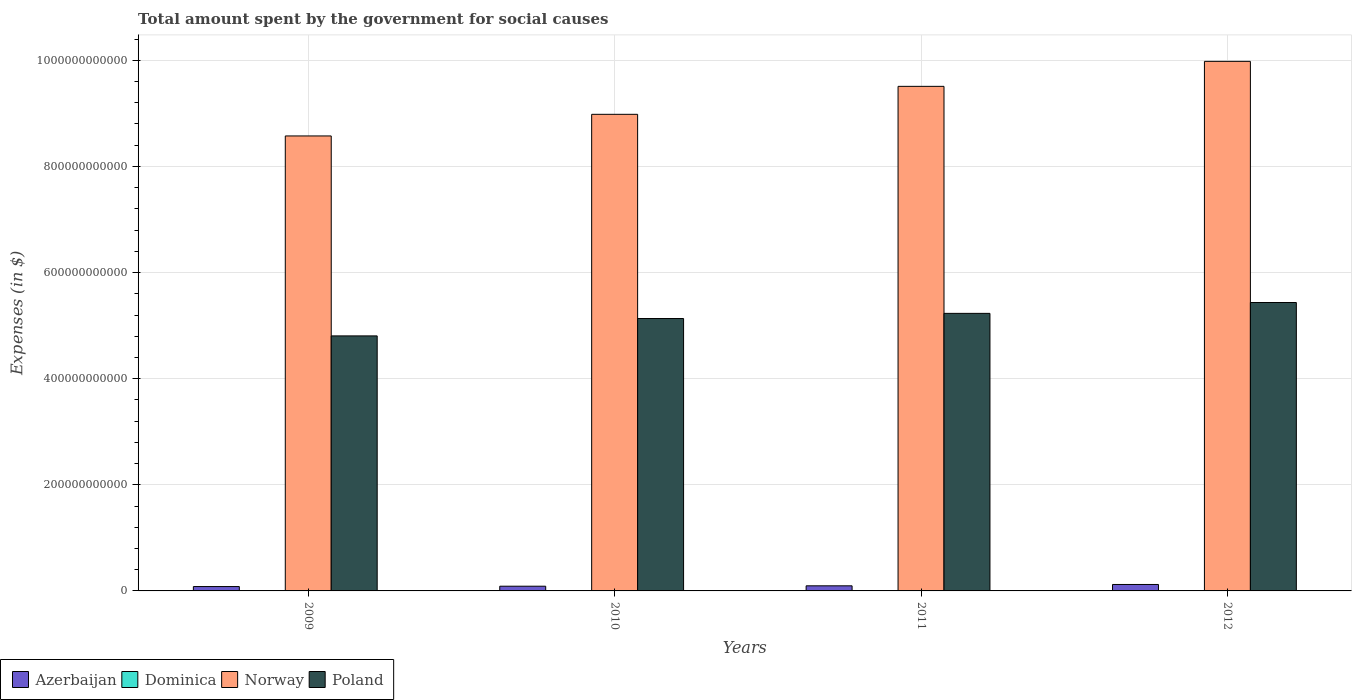Are the number of bars per tick equal to the number of legend labels?
Make the answer very short. Yes. Are the number of bars on each tick of the X-axis equal?
Keep it short and to the point. Yes. How many bars are there on the 2nd tick from the left?
Offer a very short reply. 4. In how many cases, is the number of bars for a given year not equal to the number of legend labels?
Provide a succinct answer. 0. What is the amount spent for social causes by the government in Dominica in 2012?
Offer a very short reply. 3.38e+08. Across all years, what is the maximum amount spent for social causes by the government in Azerbaijan?
Keep it short and to the point. 1.21e+1. Across all years, what is the minimum amount spent for social causes by the government in Norway?
Your answer should be very brief. 8.57e+11. In which year was the amount spent for social causes by the government in Poland maximum?
Provide a succinct answer. 2012. In which year was the amount spent for social causes by the government in Poland minimum?
Your answer should be compact. 2009. What is the total amount spent for social causes by the government in Poland in the graph?
Offer a terse response. 2.06e+12. What is the difference between the amount spent for social causes by the government in Dominica in 2010 and that in 2011?
Ensure brevity in your answer.  -1.13e+07. What is the difference between the amount spent for social causes by the government in Dominica in 2009 and the amount spent for social causes by the government in Poland in 2012?
Provide a succinct answer. -5.43e+11. What is the average amount spent for social causes by the government in Dominica per year?
Keep it short and to the point. 3.18e+08. In the year 2010, what is the difference between the amount spent for social causes by the government in Norway and amount spent for social causes by the government in Dominica?
Give a very brief answer. 8.98e+11. In how many years, is the amount spent for social causes by the government in Dominica greater than 1000000000000 $?
Offer a very short reply. 0. What is the ratio of the amount spent for social causes by the government in Azerbaijan in 2011 to that in 2012?
Give a very brief answer. 0.79. Is the amount spent for social causes by the government in Dominica in 2009 less than that in 2010?
Offer a terse response. Yes. Is the difference between the amount spent for social causes by the government in Norway in 2009 and 2011 greater than the difference between the amount spent for social causes by the government in Dominica in 2009 and 2011?
Give a very brief answer. No. What is the difference between the highest and the second highest amount spent for social causes by the government in Azerbaijan?
Your answer should be very brief. 2.52e+09. What is the difference between the highest and the lowest amount spent for social causes by the government in Norway?
Your answer should be very brief. 1.41e+11. In how many years, is the amount spent for social causes by the government in Azerbaijan greater than the average amount spent for social causes by the government in Azerbaijan taken over all years?
Offer a terse response. 1. Is the sum of the amount spent for social causes by the government in Norway in 2011 and 2012 greater than the maximum amount spent for social causes by the government in Poland across all years?
Provide a succinct answer. Yes. Is it the case that in every year, the sum of the amount spent for social causes by the government in Dominica and amount spent for social causes by the government in Azerbaijan is greater than the sum of amount spent for social causes by the government in Poland and amount spent for social causes by the government in Norway?
Your response must be concise. Yes. What does the 2nd bar from the right in 2012 represents?
Your answer should be compact. Norway. How many years are there in the graph?
Ensure brevity in your answer.  4. What is the difference between two consecutive major ticks on the Y-axis?
Provide a short and direct response. 2.00e+11. Does the graph contain any zero values?
Provide a short and direct response. No. How are the legend labels stacked?
Your answer should be very brief. Horizontal. What is the title of the graph?
Your answer should be compact. Total amount spent by the government for social causes. What is the label or title of the Y-axis?
Offer a very short reply. Expenses (in $). What is the Expenses (in $) in Azerbaijan in 2009?
Keep it short and to the point. 8.22e+09. What is the Expenses (in $) of Dominica in 2009?
Your answer should be very brief. 2.88e+08. What is the Expenses (in $) in Norway in 2009?
Give a very brief answer. 8.57e+11. What is the Expenses (in $) in Poland in 2009?
Your response must be concise. 4.81e+11. What is the Expenses (in $) of Azerbaijan in 2010?
Your response must be concise. 8.86e+09. What is the Expenses (in $) of Dominica in 2010?
Your response must be concise. 3.17e+08. What is the Expenses (in $) of Norway in 2010?
Give a very brief answer. 8.98e+11. What is the Expenses (in $) in Poland in 2010?
Provide a succinct answer. 5.13e+11. What is the Expenses (in $) in Azerbaijan in 2011?
Ensure brevity in your answer.  9.62e+09. What is the Expenses (in $) in Dominica in 2011?
Provide a short and direct response. 3.28e+08. What is the Expenses (in $) of Norway in 2011?
Offer a very short reply. 9.51e+11. What is the Expenses (in $) in Poland in 2011?
Offer a very short reply. 5.23e+11. What is the Expenses (in $) in Azerbaijan in 2012?
Make the answer very short. 1.21e+1. What is the Expenses (in $) of Dominica in 2012?
Keep it short and to the point. 3.38e+08. What is the Expenses (in $) of Norway in 2012?
Offer a very short reply. 9.98e+11. What is the Expenses (in $) in Poland in 2012?
Provide a short and direct response. 5.44e+11. Across all years, what is the maximum Expenses (in $) of Azerbaijan?
Provide a short and direct response. 1.21e+1. Across all years, what is the maximum Expenses (in $) of Dominica?
Provide a succinct answer. 3.38e+08. Across all years, what is the maximum Expenses (in $) of Norway?
Keep it short and to the point. 9.98e+11. Across all years, what is the maximum Expenses (in $) in Poland?
Give a very brief answer. 5.44e+11. Across all years, what is the minimum Expenses (in $) in Azerbaijan?
Ensure brevity in your answer.  8.22e+09. Across all years, what is the minimum Expenses (in $) in Dominica?
Keep it short and to the point. 2.88e+08. Across all years, what is the minimum Expenses (in $) in Norway?
Provide a succinct answer. 8.57e+11. Across all years, what is the minimum Expenses (in $) of Poland?
Make the answer very short. 4.81e+11. What is the total Expenses (in $) in Azerbaijan in the graph?
Offer a terse response. 3.88e+1. What is the total Expenses (in $) in Dominica in the graph?
Your response must be concise. 1.27e+09. What is the total Expenses (in $) of Norway in the graph?
Provide a succinct answer. 3.70e+12. What is the total Expenses (in $) in Poland in the graph?
Provide a succinct answer. 2.06e+12. What is the difference between the Expenses (in $) of Azerbaijan in 2009 and that in 2010?
Offer a very short reply. -6.47e+08. What is the difference between the Expenses (in $) in Dominica in 2009 and that in 2010?
Your response must be concise. -2.83e+07. What is the difference between the Expenses (in $) of Norway in 2009 and that in 2010?
Keep it short and to the point. -4.08e+1. What is the difference between the Expenses (in $) of Poland in 2009 and that in 2010?
Provide a short and direct response. -3.28e+1. What is the difference between the Expenses (in $) in Azerbaijan in 2009 and that in 2011?
Your answer should be compact. -1.41e+09. What is the difference between the Expenses (in $) of Dominica in 2009 and that in 2011?
Make the answer very short. -3.96e+07. What is the difference between the Expenses (in $) in Norway in 2009 and that in 2011?
Your answer should be compact. -9.35e+1. What is the difference between the Expenses (in $) in Poland in 2009 and that in 2011?
Give a very brief answer. -4.25e+1. What is the difference between the Expenses (in $) of Azerbaijan in 2009 and that in 2012?
Your response must be concise. -3.93e+09. What is the difference between the Expenses (in $) of Dominica in 2009 and that in 2012?
Your answer should be compact. -4.95e+07. What is the difference between the Expenses (in $) in Norway in 2009 and that in 2012?
Your answer should be very brief. -1.41e+11. What is the difference between the Expenses (in $) of Poland in 2009 and that in 2012?
Make the answer very short. -6.29e+1. What is the difference between the Expenses (in $) of Azerbaijan in 2010 and that in 2011?
Your response must be concise. -7.60e+08. What is the difference between the Expenses (in $) in Dominica in 2010 and that in 2011?
Your response must be concise. -1.13e+07. What is the difference between the Expenses (in $) in Norway in 2010 and that in 2011?
Provide a short and direct response. -5.27e+1. What is the difference between the Expenses (in $) in Poland in 2010 and that in 2011?
Make the answer very short. -9.70e+09. What is the difference between the Expenses (in $) of Azerbaijan in 2010 and that in 2012?
Your answer should be compact. -3.28e+09. What is the difference between the Expenses (in $) in Dominica in 2010 and that in 2012?
Your answer should be very brief. -2.12e+07. What is the difference between the Expenses (in $) of Norway in 2010 and that in 2012?
Offer a very short reply. -9.98e+1. What is the difference between the Expenses (in $) in Poland in 2010 and that in 2012?
Offer a very short reply. -3.02e+1. What is the difference between the Expenses (in $) in Azerbaijan in 2011 and that in 2012?
Ensure brevity in your answer.  -2.52e+09. What is the difference between the Expenses (in $) in Dominica in 2011 and that in 2012?
Your response must be concise. -9.90e+06. What is the difference between the Expenses (in $) in Norway in 2011 and that in 2012?
Provide a succinct answer. -4.71e+1. What is the difference between the Expenses (in $) in Poland in 2011 and that in 2012?
Your answer should be compact. -2.05e+1. What is the difference between the Expenses (in $) of Azerbaijan in 2009 and the Expenses (in $) of Dominica in 2010?
Offer a very short reply. 7.90e+09. What is the difference between the Expenses (in $) of Azerbaijan in 2009 and the Expenses (in $) of Norway in 2010?
Your response must be concise. -8.90e+11. What is the difference between the Expenses (in $) of Azerbaijan in 2009 and the Expenses (in $) of Poland in 2010?
Your answer should be compact. -5.05e+11. What is the difference between the Expenses (in $) in Dominica in 2009 and the Expenses (in $) in Norway in 2010?
Your response must be concise. -8.98e+11. What is the difference between the Expenses (in $) in Dominica in 2009 and the Expenses (in $) in Poland in 2010?
Your answer should be very brief. -5.13e+11. What is the difference between the Expenses (in $) in Norway in 2009 and the Expenses (in $) in Poland in 2010?
Provide a succinct answer. 3.44e+11. What is the difference between the Expenses (in $) of Azerbaijan in 2009 and the Expenses (in $) of Dominica in 2011?
Offer a terse response. 7.89e+09. What is the difference between the Expenses (in $) in Azerbaijan in 2009 and the Expenses (in $) in Norway in 2011?
Provide a short and direct response. -9.43e+11. What is the difference between the Expenses (in $) in Azerbaijan in 2009 and the Expenses (in $) in Poland in 2011?
Give a very brief answer. -5.15e+11. What is the difference between the Expenses (in $) in Dominica in 2009 and the Expenses (in $) in Norway in 2011?
Make the answer very short. -9.51e+11. What is the difference between the Expenses (in $) of Dominica in 2009 and the Expenses (in $) of Poland in 2011?
Give a very brief answer. -5.23e+11. What is the difference between the Expenses (in $) in Norway in 2009 and the Expenses (in $) in Poland in 2011?
Offer a very short reply. 3.34e+11. What is the difference between the Expenses (in $) in Azerbaijan in 2009 and the Expenses (in $) in Dominica in 2012?
Offer a terse response. 7.88e+09. What is the difference between the Expenses (in $) in Azerbaijan in 2009 and the Expenses (in $) in Norway in 2012?
Keep it short and to the point. -9.90e+11. What is the difference between the Expenses (in $) in Azerbaijan in 2009 and the Expenses (in $) in Poland in 2012?
Keep it short and to the point. -5.35e+11. What is the difference between the Expenses (in $) of Dominica in 2009 and the Expenses (in $) of Norway in 2012?
Your answer should be compact. -9.98e+11. What is the difference between the Expenses (in $) in Dominica in 2009 and the Expenses (in $) in Poland in 2012?
Your answer should be compact. -5.43e+11. What is the difference between the Expenses (in $) of Norway in 2009 and the Expenses (in $) of Poland in 2012?
Offer a terse response. 3.14e+11. What is the difference between the Expenses (in $) in Azerbaijan in 2010 and the Expenses (in $) in Dominica in 2011?
Keep it short and to the point. 8.54e+09. What is the difference between the Expenses (in $) of Azerbaijan in 2010 and the Expenses (in $) of Norway in 2011?
Offer a very short reply. -9.42e+11. What is the difference between the Expenses (in $) of Azerbaijan in 2010 and the Expenses (in $) of Poland in 2011?
Your answer should be very brief. -5.14e+11. What is the difference between the Expenses (in $) of Dominica in 2010 and the Expenses (in $) of Norway in 2011?
Ensure brevity in your answer.  -9.51e+11. What is the difference between the Expenses (in $) in Dominica in 2010 and the Expenses (in $) in Poland in 2011?
Make the answer very short. -5.23e+11. What is the difference between the Expenses (in $) in Norway in 2010 and the Expenses (in $) in Poland in 2011?
Provide a short and direct response. 3.75e+11. What is the difference between the Expenses (in $) of Azerbaijan in 2010 and the Expenses (in $) of Dominica in 2012?
Offer a terse response. 8.53e+09. What is the difference between the Expenses (in $) of Azerbaijan in 2010 and the Expenses (in $) of Norway in 2012?
Your answer should be compact. -9.89e+11. What is the difference between the Expenses (in $) in Azerbaijan in 2010 and the Expenses (in $) in Poland in 2012?
Make the answer very short. -5.35e+11. What is the difference between the Expenses (in $) in Dominica in 2010 and the Expenses (in $) in Norway in 2012?
Offer a terse response. -9.98e+11. What is the difference between the Expenses (in $) of Dominica in 2010 and the Expenses (in $) of Poland in 2012?
Offer a terse response. -5.43e+11. What is the difference between the Expenses (in $) of Norway in 2010 and the Expenses (in $) of Poland in 2012?
Give a very brief answer. 3.55e+11. What is the difference between the Expenses (in $) of Azerbaijan in 2011 and the Expenses (in $) of Dominica in 2012?
Give a very brief answer. 9.29e+09. What is the difference between the Expenses (in $) in Azerbaijan in 2011 and the Expenses (in $) in Norway in 2012?
Offer a very short reply. -9.88e+11. What is the difference between the Expenses (in $) in Azerbaijan in 2011 and the Expenses (in $) in Poland in 2012?
Give a very brief answer. -5.34e+11. What is the difference between the Expenses (in $) in Dominica in 2011 and the Expenses (in $) in Norway in 2012?
Ensure brevity in your answer.  -9.98e+11. What is the difference between the Expenses (in $) in Dominica in 2011 and the Expenses (in $) in Poland in 2012?
Your answer should be compact. -5.43e+11. What is the difference between the Expenses (in $) of Norway in 2011 and the Expenses (in $) of Poland in 2012?
Ensure brevity in your answer.  4.07e+11. What is the average Expenses (in $) of Azerbaijan per year?
Your answer should be compact. 9.71e+09. What is the average Expenses (in $) in Dominica per year?
Give a very brief answer. 3.18e+08. What is the average Expenses (in $) of Norway per year?
Give a very brief answer. 9.26e+11. What is the average Expenses (in $) in Poland per year?
Your answer should be compact. 5.15e+11. In the year 2009, what is the difference between the Expenses (in $) of Azerbaijan and Expenses (in $) of Dominica?
Offer a terse response. 7.93e+09. In the year 2009, what is the difference between the Expenses (in $) of Azerbaijan and Expenses (in $) of Norway?
Give a very brief answer. -8.49e+11. In the year 2009, what is the difference between the Expenses (in $) in Azerbaijan and Expenses (in $) in Poland?
Provide a succinct answer. -4.72e+11. In the year 2009, what is the difference between the Expenses (in $) in Dominica and Expenses (in $) in Norway?
Your answer should be very brief. -8.57e+11. In the year 2009, what is the difference between the Expenses (in $) of Dominica and Expenses (in $) of Poland?
Your answer should be compact. -4.80e+11. In the year 2009, what is the difference between the Expenses (in $) of Norway and Expenses (in $) of Poland?
Offer a terse response. 3.77e+11. In the year 2010, what is the difference between the Expenses (in $) in Azerbaijan and Expenses (in $) in Dominica?
Your answer should be compact. 8.55e+09. In the year 2010, what is the difference between the Expenses (in $) in Azerbaijan and Expenses (in $) in Norway?
Offer a very short reply. -8.89e+11. In the year 2010, what is the difference between the Expenses (in $) in Azerbaijan and Expenses (in $) in Poland?
Give a very brief answer. -5.05e+11. In the year 2010, what is the difference between the Expenses (in $) of Dominica and Expenses (in $) of Norway?
Your answer should be compact. -8.98e+11. In the year 2010, what is the difference between the Expenses (in $) in Dominica and Expenses (in $) in Poland?
Offer a very short reply. -5.13e+11. In the year 2010, what is the difference between the Expenses (in $) in Norway and Expenses (in $) in Poland?
Your answer should be very brief. 3.85e+11. In the year 2011, what is the difference between the Expenses (in $) of Azerbaijan and Expenses (in $) of Dominica?
Give a very brief answer. 9.30e+09. In the year 2011, what is the difference between the Expenses (in $) in Azerbaijan and Expenses (in $) in Norway?
Give a very brief answer. -9.41e+11. In the year 2011, what is the difference between the Expenses (in $) of Azerbaijan and Expenses (in $) of Poland?
Offer a terse response. -5.13e+11. In the year 2011, what is the difference between the Expenses (in $) in Dominica and Expenses (in $) in Norway?
Keep it short and to the point. -9.51e+11. In the year 2011, what is the difference between the Expenses (in $) in Dominica and Expenses (in $) in Poland?
Offer a very short reply. -5.23e+11. In the year 2011, what is the difference between the Expenses (in $) in Norway and Expenses (in $) in Poland?
Offer a very short reply. 4.28e+11. In the year 2012, what is the difference between the Expenses (in $) of Azerbaijan and Expenses (in $) of Dominica?
Make the answer very short. 1.18e+1. In the year 2012, what is the difference between the Expenses (in $) in Azerbaijan and Expenses (in $) in Norway?
Keep it short and to the point. -9.86e+11. In the year 2012, what is the difference between the Expenses (in $) of Azerbaijan and Expenses (in $) of Poland?
Make the answer very short. -5.31e+11. In the year 2012, what is the difference between the Expenses (in $) of Dominica and Expenses (in $) of Norway?
Give a very brief answer. -9.98e+11. In the year 2012, what is the difference between the Expenses (in $) of Dominica and Expenses (in $) of Poland?
Ensure brevity in your answer.  -5.43e+11. In the year 2012, what is the difference between the Expenses (in $) of Norway and Expenses (in $) of Poland?
Give a very brief answer. 4.54e+11. What is the ratio of the Expenses (in $) in Azerbaijan in 2009 to that in 2010?
Your answer should be very brief. 0.93. What is the ratio of the Expenses (in $) in Dominica in 2009 to that in 2010?
Your answer should be compact. 0.91. What is the ratio of the Expenses (in $) of Norway in 2009 to that in 2010?
Your response must be concise. 0.95. What is the ratio of the Expenses (in $) in Poland in 2009 to that in 2010?
Offer a terse response. 0.94. What is the ratio of the Expenses (in $) of Azerbaijan in 2009 to that in 2011?
Provide a succinct answer. 0.85. What is the ratio of the Expenses (in $) of Dominica in 2009 to that in 2011?
Provide a short and direct response. 0.88. What is the ratio of the Expenses (in $) in Norway in 2009 to that in 2011?
Provide a succinct answer. 0.9. What is the ratio of the Expenses (in $) of Poland in 2009 to that in 2011?
Offer a very short reply. 0.92. What is the ratio of the Expenses (in $) in Azerbaijan in 2009 to that in 2012?
Make the answer very short. 0.68. What is the ratio of the Expenses (in $) in Dominica in 2009 to that in 2012?
Your answer should be compact. 0.85. What is the ratio of the Expenses (in $) of Norway in 2009 to that in 2012?
Offer a very short reply. 0.86. What is the ratio of the Expenses (in $) of Poland in 2009 to that in 2012?
Provide a succinct answer. 0.88. What is the ratio of the Expenses (in $) in Azerbaijan in 2010 to that in 2011?
Give a very brief answer. 0.92. What is the ratio of the Expenses (in $) of Dominica in 2010 to that in 2011?
Make the answer very short. 0.97. What is the ratio of the Expenses (in $) in Norway in 2010 to that in 2011?
Make the answer very short. 0.94. What is the ratio of the Expenses (in $) of Poland in 2010 to that in 2011?
Make the answer very short. 0.98. What is the ratio of the Expenses (in $) of Azerbaijan in 2010 to that in 2012?
Offer a very short reply. 0.73. What is the ratio of the Expenses (in $) of Dominica in 2010 to that in 2012?
Keep it short and to the point. 0.94. What is the ratio of the Expenses (in $) of Norway in 2010 to that in 2012?
Give a very brief answer. 0.9. What is the ratio of the Expenses (in $) in Poland in 2010 to that in 2012?
Give a very brief answer. 0.94. What is the ratio of the Expenses (in $) of Azerbaijan in 2011 to that in 2012?
Offer a very short reply. 0.79. What is the ratio of the Expenses (in $) of Dominica in 2011 to that in 2012?
Make the answer very short. 0.97. What is the ratio of the Expenses (in $) in Norway in 2011 to that in 2012?
Offer a terse response. 0.95. What is the ratio of the Expenses (in $) of Poland in 2011 to that in 2012?
Provide a succinct answer. 0.96. What is the difference between the highest and the second highest Expenses (in $) of Azerbaijan?
Ensure brevity in your answer.  2.52e+09. What is the difference between the highest and the second highest Expenses (in $) in Dominica?
Keep it short and to the point. 9.90e+06. What is the difference between the highest and the second highest Expenses (in $) of Norway?
Give a very brief answer. 4.71e+1. What is the difference between the highest and the second highest Expenses (in $) in Poland?
Keep it short and to the point. 2.05e+1. What is the difference between the highest and the lowest Expenses (in $) of Azerbaijan?
Your answer should be compact. 3.93e+09. What is the difference between the highest and the lowest Expenses (in $) of Dominica?
Give a very brief answer. 4.95e+07. What is the difference between the highest and the lowest Expenses (in $) of Norway?
Provide a short and direct response. 1.41e+11. What is the difference between the highest and the lowest Expenses (in $) of Poland?
Provide a short and direct response. 6.29e+1. 